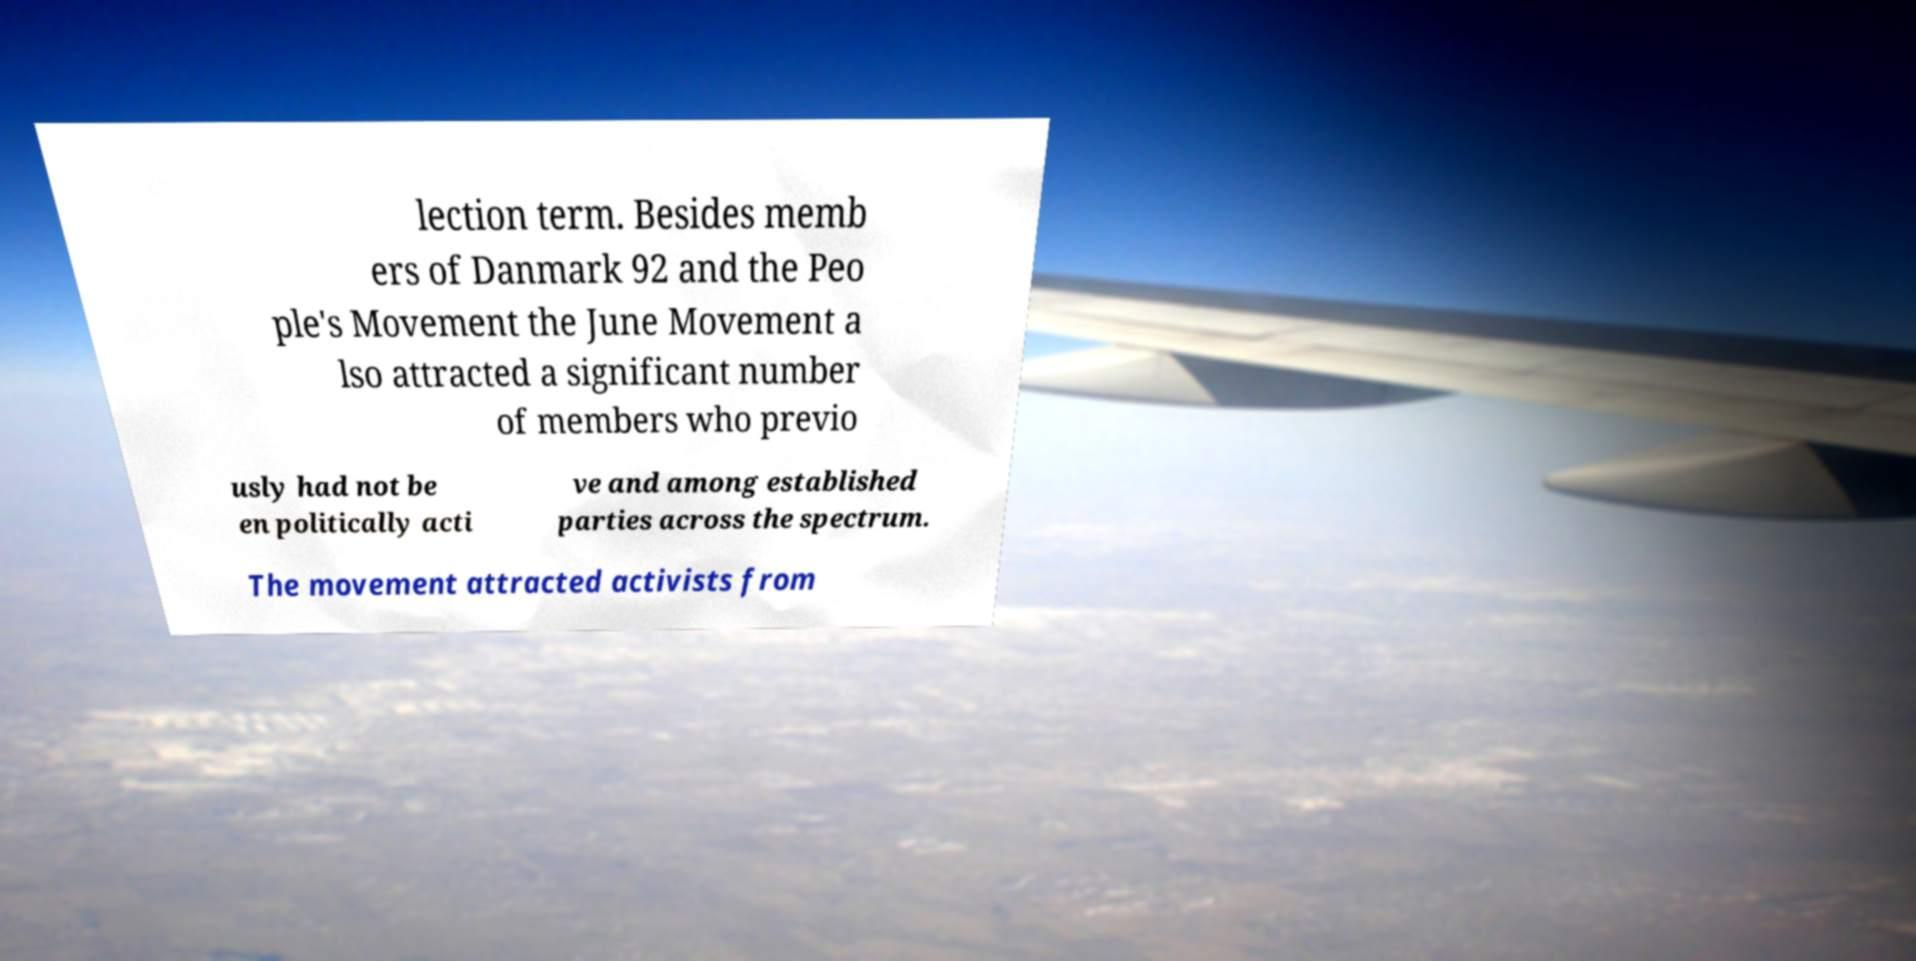Please read and relay the text visible in this image. What does it say? lection term. Besides memb ers of Danmark 92 and the Peo ple's Movement the June Movement a lso attracted a significant number of members who previo usly had not be en politically acti ve and among established parties across the spectrum. The movement attracted activists from 